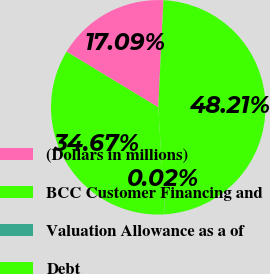<chart> <loc_0><loc_0><loc_500><loc_500><pie_chart><fcel>(Dollars in millions)<fcel>BCC Customer Financing and<fcel>Valuation Allowance as a of<fcel>Debt<nl><fcel>17.09%<fcel>48.21%<fcel>0.02%<fcel>34.67%<nl></chart> 